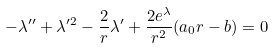<formula> <loc_0><loc_0><loc_500><loc_500>- \lambda ^ { \prime \prime } + \lambda ^ { \prime 2 } - \frac { 2 } { r } \lambda ^ { \prime } + \frac { 2 e ^ { \lambda } } { r ^ { 2 } } ( a _ { 0 } r - b ) = 0</formula> 